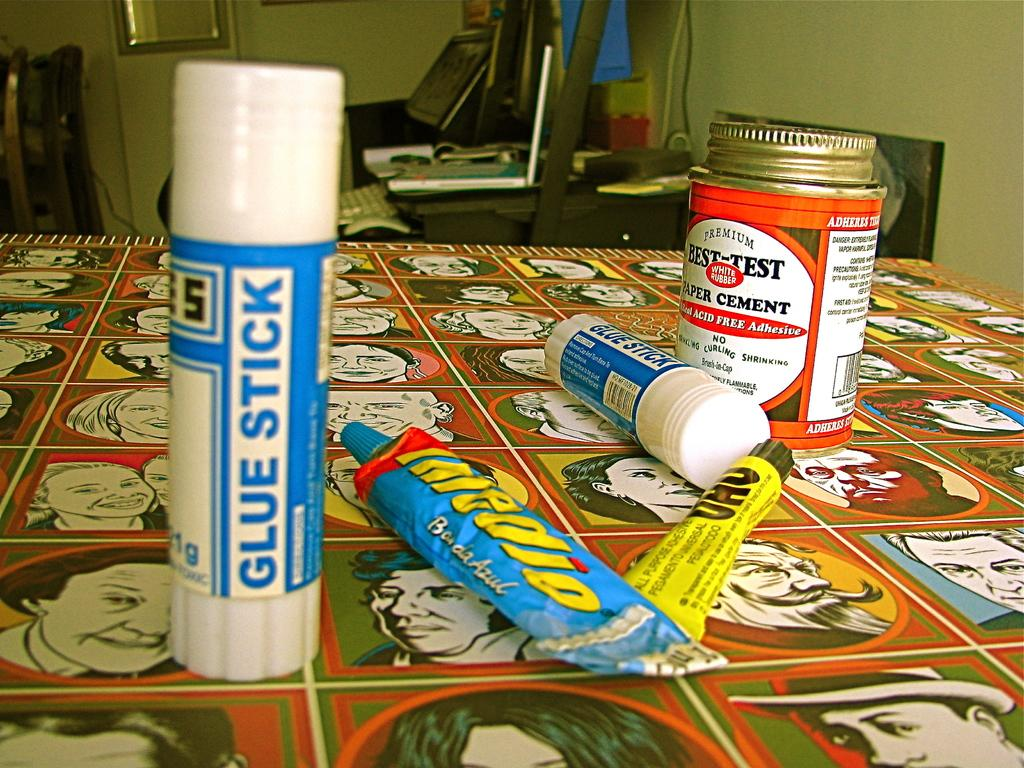<image>
Write a terse but informative summary of the picture. a Glue Stick with other glue on a table 